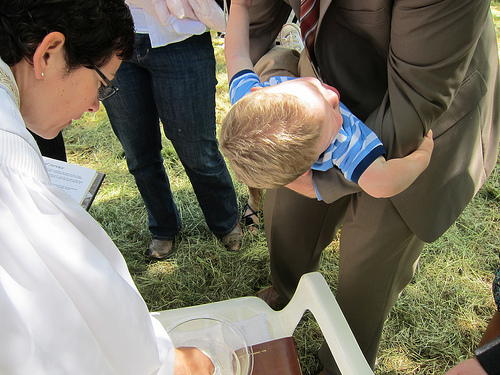<image>
Is the child on the suit? No. The child is not positioned on the suit. They may be near each other, but the child is not supported by or resting on top of the suit. Where is the man in relation to the baby? Is it to the left of the baby? No. The man is not to the left of the baby. From this viewpoint, they have a different horizontal relationship. 